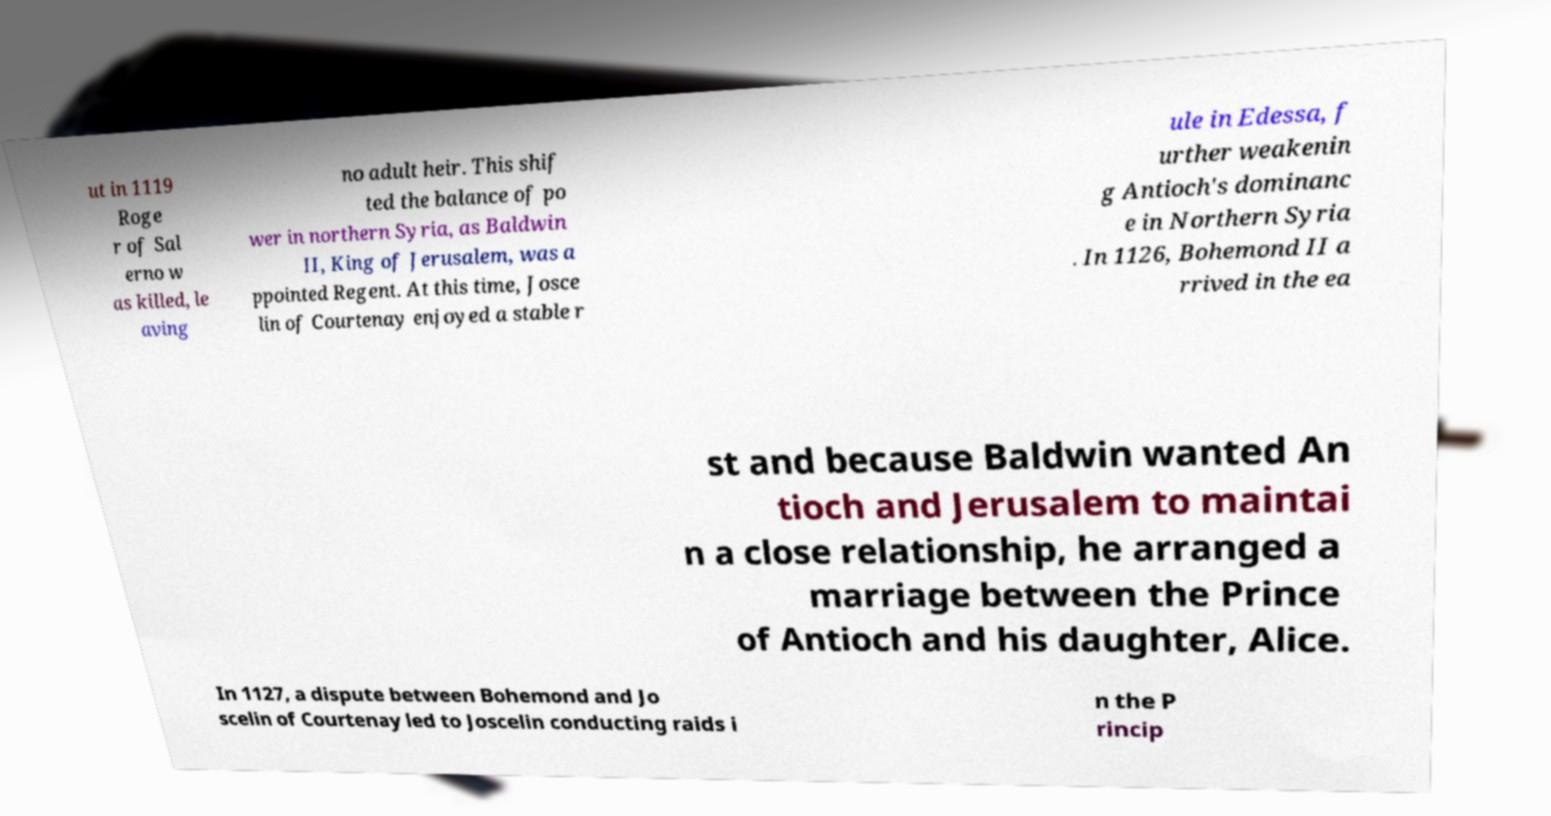There's text embedded in this image that I need extracted. Can you transcribe it verbatim? ut in 1119 Roge r of Sal erno w as killed, le aving no adult heir. This shif ted the balance of po wer in northern Syria, as Baldwin II, King of Jerusalem, was a ppointed Regent. At this time, Josce lin of Courtenay enjoyed a stable r ule in Edessa, f urther weakenin g Antioch's dominanc e in Northern Syria . In 1126, Bohemond II a rrived in the ea st and because Baldwin wanted An tioch and Jerusalem to maintai n a close relationship, he arranged a marriage between the Prince of Antioch and his daughter, Alice. In 1127, a dispute between Bohemond and Jo scelin of Courtenay led to Joscelin conducting raids i n the P rincip 